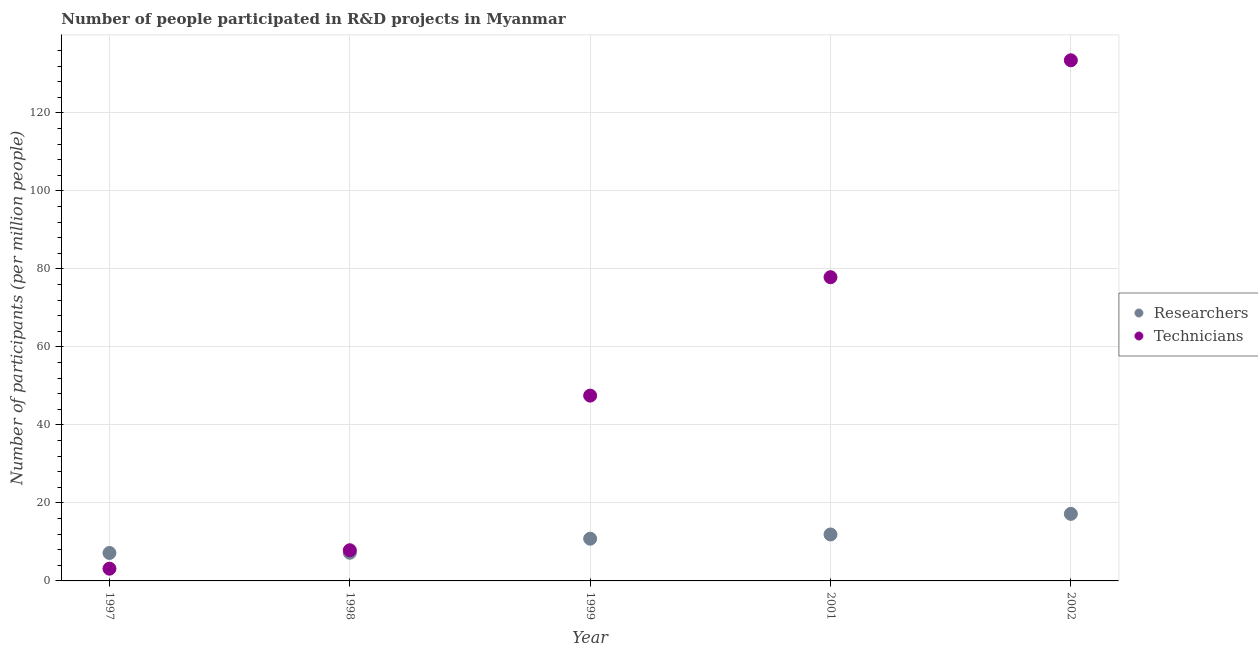How many different coloured dotlines are there?
Your answer should be very brief. 2. What is the number of researchers in 1998?
Keep it short and to the point. 7.22. Across all years, what is the maximum number of technicians?
Offer a terse response. 133.48. Across all years, what is the minimum number of technicians?
Provide a short and direct response. 3.14. In which year was the number of researchers maximum?
Offer a very short reply. 2002. In which year was the number of technicians minimum?
Your answer should be compact. 1997. What is the total number of technicians in the graph?
Your answer should be very brief. 269.86. What is the difference between the number of researchers in 1998 and that in 2001?
Make the answer very short. -4.69. What is the difference between the number of researchers in 1999 and the number of technicians in 2002?
Offer a very short reply. -122.65. What is the average number of researchers per year?
Offer a very short reply. 10.86. In the year 2001, what is the difference between the number of technicians and number of researchers?
Your answer should be compact. 65.96. What is the ratio of the number of technicians in 2001 to that in 2002?
Give a very brief answer. 0.58. Is the number of technicians in 2001 less than that in 2002?
Your response must be concise. Yes. What is the difference between the highest and the second highest number of technicians?
Offer a very short reply. 55.61. What is the difference between the highest and the lowest number of technicians?
Your response must be concise. 130.34. How many dotlines are there?
Offer a terse response. 2. How many years are there in the graph?
Your response must be concise. 5. Does the graph contain any zero values?
Provide a short and direct response. No. Where does the legend appear in the graph?
Keep it short and to the point. Center right. How are the legend labels stacked?
Your answer should be compact. Vertical. What is the title of the graph?
Provide a succinct answer. Number of people participated in R&D projects in Myanmar. What is the label or title of the X-axis?
Offer a terse response. Year. What is the label or title of the Y-axis?
Offer a very short reply. Number of participants (per million people). What is the Number of participants (per million people) of Researchers in 1997?
Offer a terse response. 7.17. What is the Number of participants (per million people) in Technicians in 1997?
Your response must be concise. 3.14. What is the Number of participants (per million people) in Researchers in 1998?
Keep it short and to the point. 7.22. What is the Number of participants (per million people) in Technicians in 1998?
Give a very brief answer. 7.87. What is the Number of participants (per million people) of Researchers in 1999?
Keep it short and to the point. 10.83. What is the Number of participants (per million people) in Technicians in 1999?
Ensure brevity in your answer.  47.51. What is the Number of participants (per million people) of Researchers in 2001?
Offer a very short reply. 11.91. What is the Number of participants (per million people) in Technicians in 2001?
Ensure brevity in your answer.  77.87. What is the Number of participants (per million people) of Researchers in 2002?
Give a very brief answer. 17.19. What is the Number of participants (per million people) of Technicians in 2002?
Your response must be concise. 133.48. Across all years, what is the maximum Number of participants (per million people) of Researchers?
Your answer should be compact. 17.19. Across all years, what is the maximum Number of participants (per million people) in Technicians?
Provide a short and direct response. 133.48. Across all years, what is the minimum Number of participants (per million people) of Researchers?
Your answer should be very brief. 7.17. Across all years, what is the minimum Number of participants (per million people) in Technicians?
Your answer should be compact. 3.14. What is the total Number of participants (per million people) in Researchers in the graph?
Provide a short and direct response. 54.32. What is the total Number of participants (per million people) in Technicians in the graph?
Give a very brief answer. 269.86. What is the difference between the Number of participants (per million people) of Researchers in 1997 and that in 1998?
Keep it short and to the point. -0.06. What is the difference between the Number of participants (per million people) of Technicians in 1997 and that in 1998?
Your answer should be compact. -4.73. What is the difference between the Number of participants (per million people) in Researchers in 1997 and that in 1999?
Your answer should be very brief. -3.66. What is the difference between the Number of participants (per million people) in Technicians in 1997 and that in 1999?
Offer a very short reply. -44.37. What is the difference between the Number of participants (per million people) in Researchers in 1997 and that in 2001?
Your response must be concise. -4.74. What is the difference between the Number of participants (per million people) in Technicians in 1997 and that in 2001?
Your answer should be very brief. -74.73. What is the difference between the Number of participants (per million people) of Researchers in 1997 and that in 2002?
Provide a short and direct response. -10.02. What is the difference between the Number of participants (per million people) of Technicians in 1997 and that in 2002?
Give a very brief answer. -130.34. What is the difference between the Number of participants (per million people) of Researchers in 1998 and that in 1999?
Keep it short and to the point. -3.6. What is the difference between the Number of participants (per million people) of Technicians in 1998 and that in 1999?
Your response must be concise. -39.64. What is the difference between the Number of participants (per million people) in Researchers in 1998 and that in 2001?
Give a very brief answer. -4.69. What is the difference between the Number of participants (per million people) in Technicians in 1998 and that in 2001?
Ensure brevity in your answer.  -70. What is the difference between the Number of participants (per million people) in Researchers in 1998 and that in 2002?
Keep it short and to the point. -9.97. What is the difference between the Number of participants (per million people) of Technicians in 1998 and that in 2002?
Your response must be concise. -125.61. What is the difference between the Number of participants (per million people) of Researchers in 1999 and that in 2001?
Give a very brief answer. -1.08. What is the difference between the Number of participants (per million people) in Technicians in 1999 and that in 2001?
Provide a short and direct response. -30.36. What is the difference between the Number of participants (per million people) in Researchers in 1999 and that in 2002?
Give a very brief answer. -6.36. What is the difference between the Number of participants (per million people) in Technicians in 1999 and that in 2002?
Keep it short and to the point. -85.97. What is the difference between the Number of participants (per million people) in Researchers in 2001 and that in 2002?
Provide a short and direct response. -5.28. What is the difference between the Number of participants (per million people) in Technicians in 2001 and that in 2002?
Offer a terse response. -55.61. What is the difference between the Number of participants (per million people) in Researchers in 1997 and the Number of participants (per million people) in Technicians in 1998?
Your answer should be very brief. -0.7. What is the difference between the Number of participants (per million people) of Researchers in 1997 and the Number of participants (per million people) of Technicians in 1999?
Keep it short and to the point. -40.34. What is the difference between the Number of participants (per million people) in Researchers in 1997 and the Number of participants (per million people) in Technicians in 2001?
Provide a succinct answer. -70.7. What is the difference between the Number of participants (per million people) of Researchers in 1997 and the Number of participants (per million people) of Technicians in 2002?
Your response must be concise. -126.31. What is the difference between the Number of participants (per million people) of Researchers in 1998 and the Number of participants (per million people) of Technicians in 1999?
Provide a succinct answer. -40.28. What is the difference between the Number of participants (per million people) in Researchers in 1998 and the Number of participants (per million people) in Technicians in 2001?
Your answer should be very brief. -70.65. What is the difference between the Number of participants (per million people) in Researchers in 1998 and the Number of participants (per million people) in Technicians in 2002?
Offer a very short reply. -126.25. What is the difference between the Number of participants (per million people) of Researchers in 1999 and the Number of participants (per million people) of Technicians in 2001?
Your answer should be very brief. -67.04. What is the difference between the Number of participants (per million people) of Researchers in 1999 and the Number of participants (per million people) of Technicians in 2002?
Make the answer very short. -122.65. What is the difference between the Number of participants (per million people) in Researchers in 2001 and the Number of participants (per million people) in Technicians in 2002?
Your answer should be compact. -121.57. What is the average Number of participants (per million people) of Researchers per year?
Ensure brevity in your answer.  10.86. What is the average Number of participants (per million people) of Technicians per year?
Ensure brevity in your answer.  53.97. In the year 1997, what is the difference between the Number of participants (per million people) of Researchers and Number of participants (per million people) of Technicians?
Provide a succinct answer. 4.03. In the year 1998, what is the difference between the Number of participants (per million people) in Researchers and Number of participants (per million people) in Technicians?
Provide a short and direct response. -0.65. In the year 1999, what is the difference between the Number of participants (per million people) in Researchers and Number of participants (per million people) in Technicians?
Ensure brevity in your answer.  -36.68. In the year 2001, what is the difference between the Number of participants (per million people) in Researchers and Number of participants (per million people) in Technicians?
Provide a succinct answer. -65.96. In the year 2002, what is the difference between the Number of participants (per million people) of Researchers and Number of participants (per million people) of Technicians?
Provide a succinct answer. -116.29. What is the ratio of the Number of participants (per million people) of Technicians in 1997 to that in 1998?
Give a very brief answer. 0.4. What is the ratio of the Number of participants (per million people) in Researchers in 1997 to that in 1999?
Your answer should be compact. 0.66. What is the ratio of the Number of participants (per million people) in Technicians in 1997 to that in 1999?
Keep it short and to the point. 0.07. What is the ratio of the Number of participants (per million people) in Researchers in 1997 to that in 2001?
Your response must be concise. 0.6. What is the ratio of the Number of participants (per million people) of Technicians in 1997 to that in 2001?
Your response must be concise. 0.04. What is the ratio of the Number of participants (per million people) in Researchers in 1997 to that in 2002?
Provide a short and direct response. 0.42. What is the ratio of the Number of participants (per million people) of Technicians in 1997 to that in 2002?
Offer a very short reply. 0.02. What is the ratio of the Number of participants (per million people) of Researchers in 1998 to that in 1999?
Provide a short and direct response. 0.67. What is the ratio of the Number of participants (per million people) in Technicians in 1998 to that in 1999?
Give a very brief answer. 0.17. What is the ratio of the Number of participants (per million people) in Researchers in 1998 to that in 2001?
Provide a short and direct response. 0.61. What is the ratio of the Number of participants (per million people) in Technicians in 1998 to that in 2001?
Offer a terse response. 0.1. What is the ratio of the Number of participants (per million people) of Researchers in 1998 to that in 2002?
Offer a terse response. 0.42. What is the ratio of the Number of participants (per million people) in Technicians in 1998 to that in 2002?
Offer a very short reply. 0.06. What is the ratio of the Number of participants (per million people) in Researchers in 1999 to that in 2001?
Provide a short and direct response. 0.91. What is the ratio of the Number of participants (per million people) in Technicians in 1999 to that in 2001?
Keep it short and to the point. 0.61. What is the ratio of the Number of participants (per million people) in Researchers in 1999 to that in 2002?
Your response must be concise. 0.63. What is the ratio of the Number of participants (per million people) in Technicians in 1999 to that in 2002?
Make the answer very short. 0.36. What is the ratio of the Number of participants (per million people) in Researchers in 2001 to that in 2002?
Make the answer very short. 0.69. What is the ratio of the Number of participants (per million people) of Technicians in 2001 to that in 2002?
Make the answer very short. 0.58. What is the difference between the highest and the second highest Number of participants (per million people) of Researchers?
Provide a succinct answer. 5.28. What is the difference between the highest and the second highest Number of participants (per million people) in Technicians?
Your response must be concise. 55.61. What is the difference between the highest and the lowest Number of participants (per million people) of Researchers?
Your answer should be very brief. 10.02. What is the difference between the highest and the lowest Number of participants (per million people) in Technicians?
Ensure brevity in your answer.  130.34. 